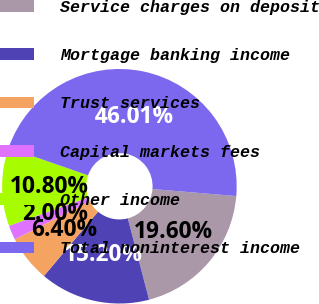Convert chart to OTSL. <chart><loc_0><loc_0><loc_500><loc_500><pie_chart><fcel>Service charges on deposit<fcel>Mortgage banking income<fcel>Trust services<fcel>Capital markets fees<fcel>Other income<fcel>Total noninterest income<nl><fcel>19.6%<fcel>15.2%<fcel>6.4%<fcel>2.0%<fcel>10.8%<fcel>46.01%<nl></chart> 